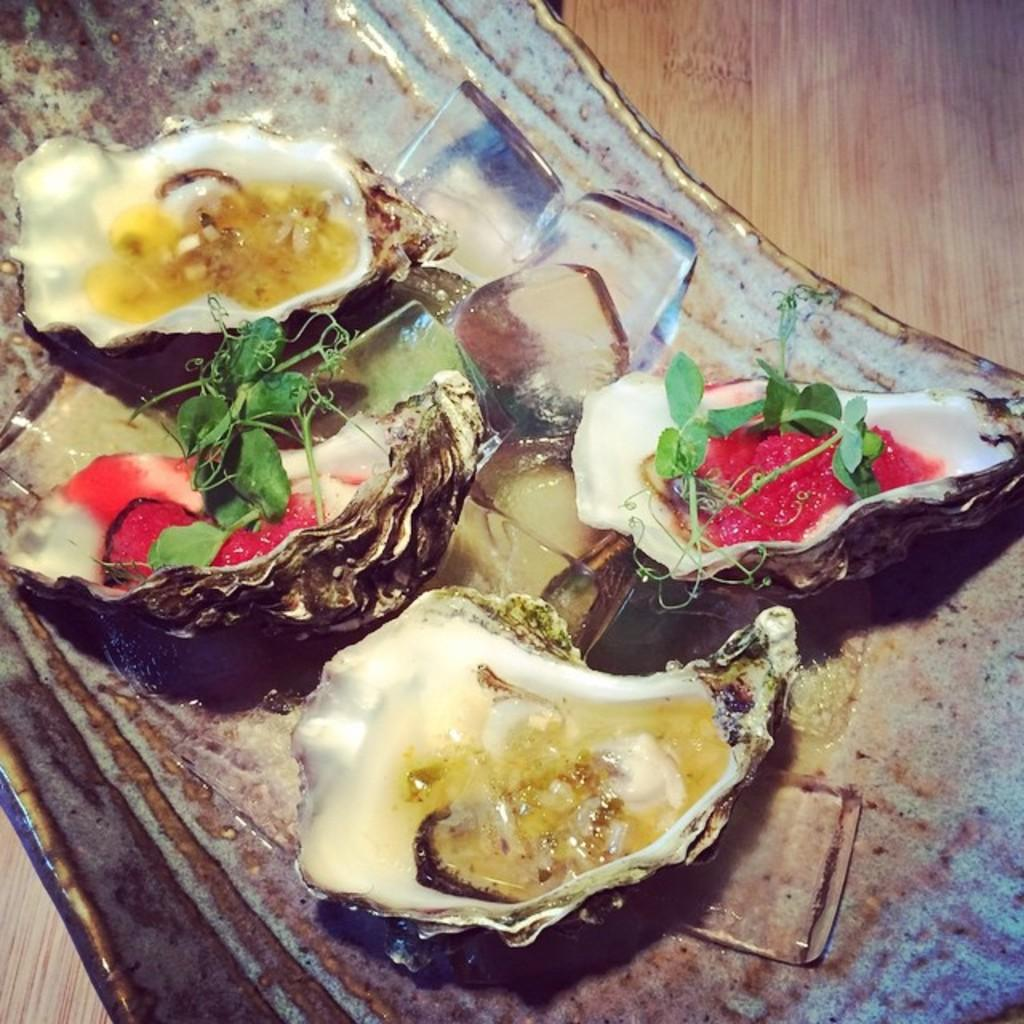What type of seafood can be seen in the image? There are oysters in the image. What type of plant material is present in the image? There are leaves in the image. What is used to keep the oysters and other items cold in the image? There are ice cubes in the image. What is the surface made of that the objects are placed on? The objects are placed on a wooden surface. How many different types of objects can be seen in the image? There are oysters, leaves, ice cubes, and other objects in the image. What type of record can be seen spinning on the wooden surface in the image? There is no record present in the image; it only contains oysters, leaves, ice cubes, and other objects. 